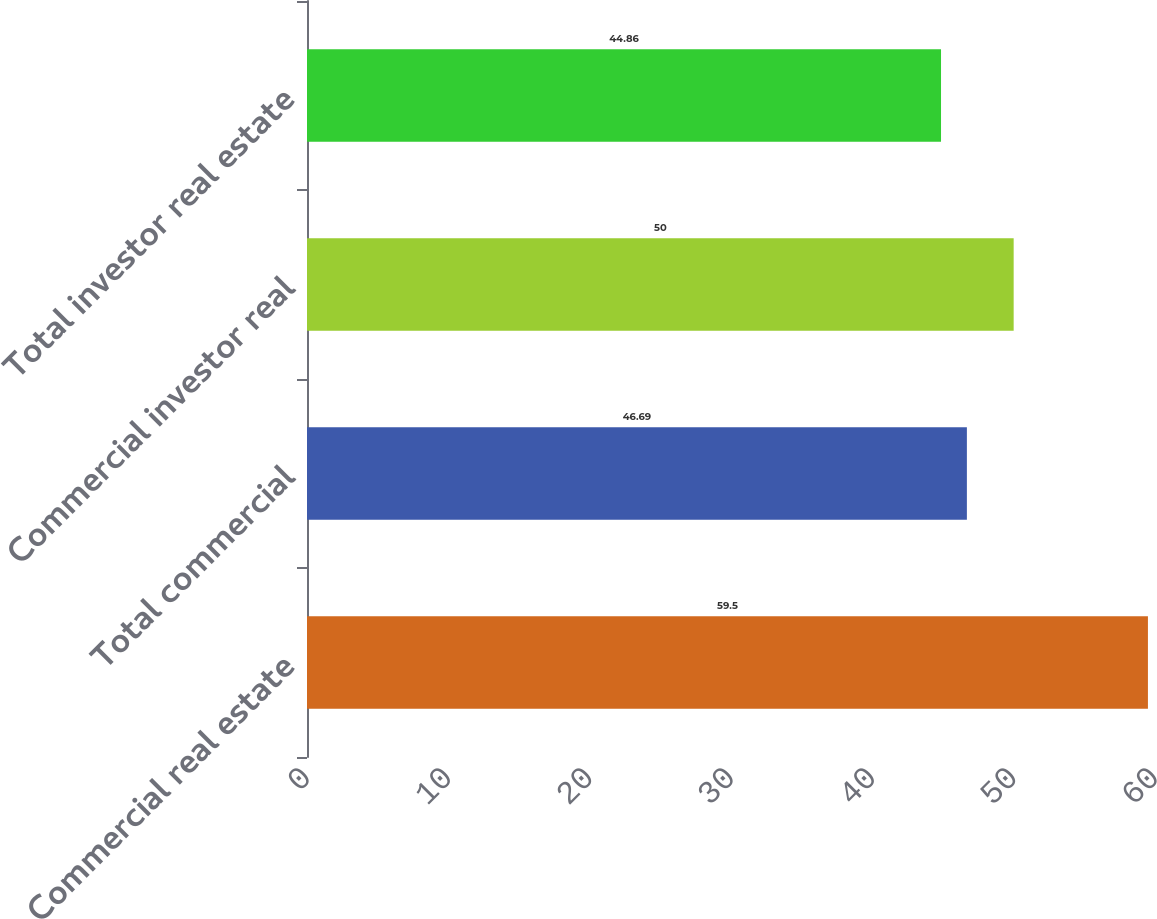Convert chart to OTSL. <chart><loc_0><loc_0><loc_500><loc_500><bar_chart><fcel>Commercial real estate<fcel>Total commercial<fcel>Commercial investor real<fcel>Total investor real estate<nl><fcel>59.5<fcel>46.69<fcel>50<fcel>44.86<nl></chart> 